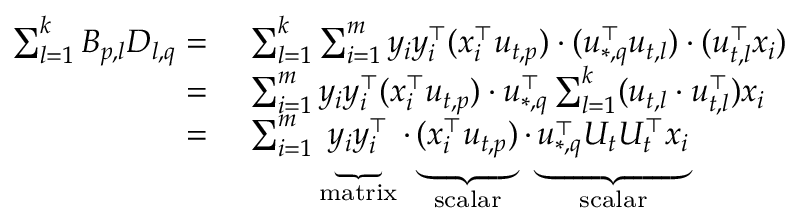Convert formula to latex. <formula><loc_0><loc_0><loc_500><loc_500>\begin{array} { r l } { \sum _ { l = 1 } ^ { k } B _ { p , l } D _ { l , q } = } & { \sum _ { l = 1 } ^ { k } \sum _ { i = 1 } ^ { m } y _ { i } y _ { i } ^ { \top } ( x _ { i } ^ { \top } u _ { t , p } ) \cdot ( u _ { * , q } ^ { \top } u _ { t , l } ) \cdot ( u _ { t , l } ^ { \top } x _ { i } ) } \\ { = } & { \sum _ { i = 1 } ^ { m } y _ { i } y _ { i } ^ { \top } ( x _ { i } ^ { \top } u _ { t , p } ) \cdot u _ { * , q } ^ { \top } \sum _ { l = 1 } ^ { k } ( u _ { t , l } \cdot u _ { t , l } ^ { \top } ) x _ { i } } \\ { = } & { \sum _ { i = 1 } ^ { m } \underbrace { y _ { i } y _ { i } ^ { \top } } _ { m a t r i x } \cdot \underbrace { ( x _ { i } ^ { \top } u _ { t , p } ) } _ { s c a l a r } \cdot \underbrace { u _ { * , q } ^ { \top } U _ { t } U _ { t } ^ { \top } x _ { i } } _ { s c a l a r } } \end{array}</formula> 